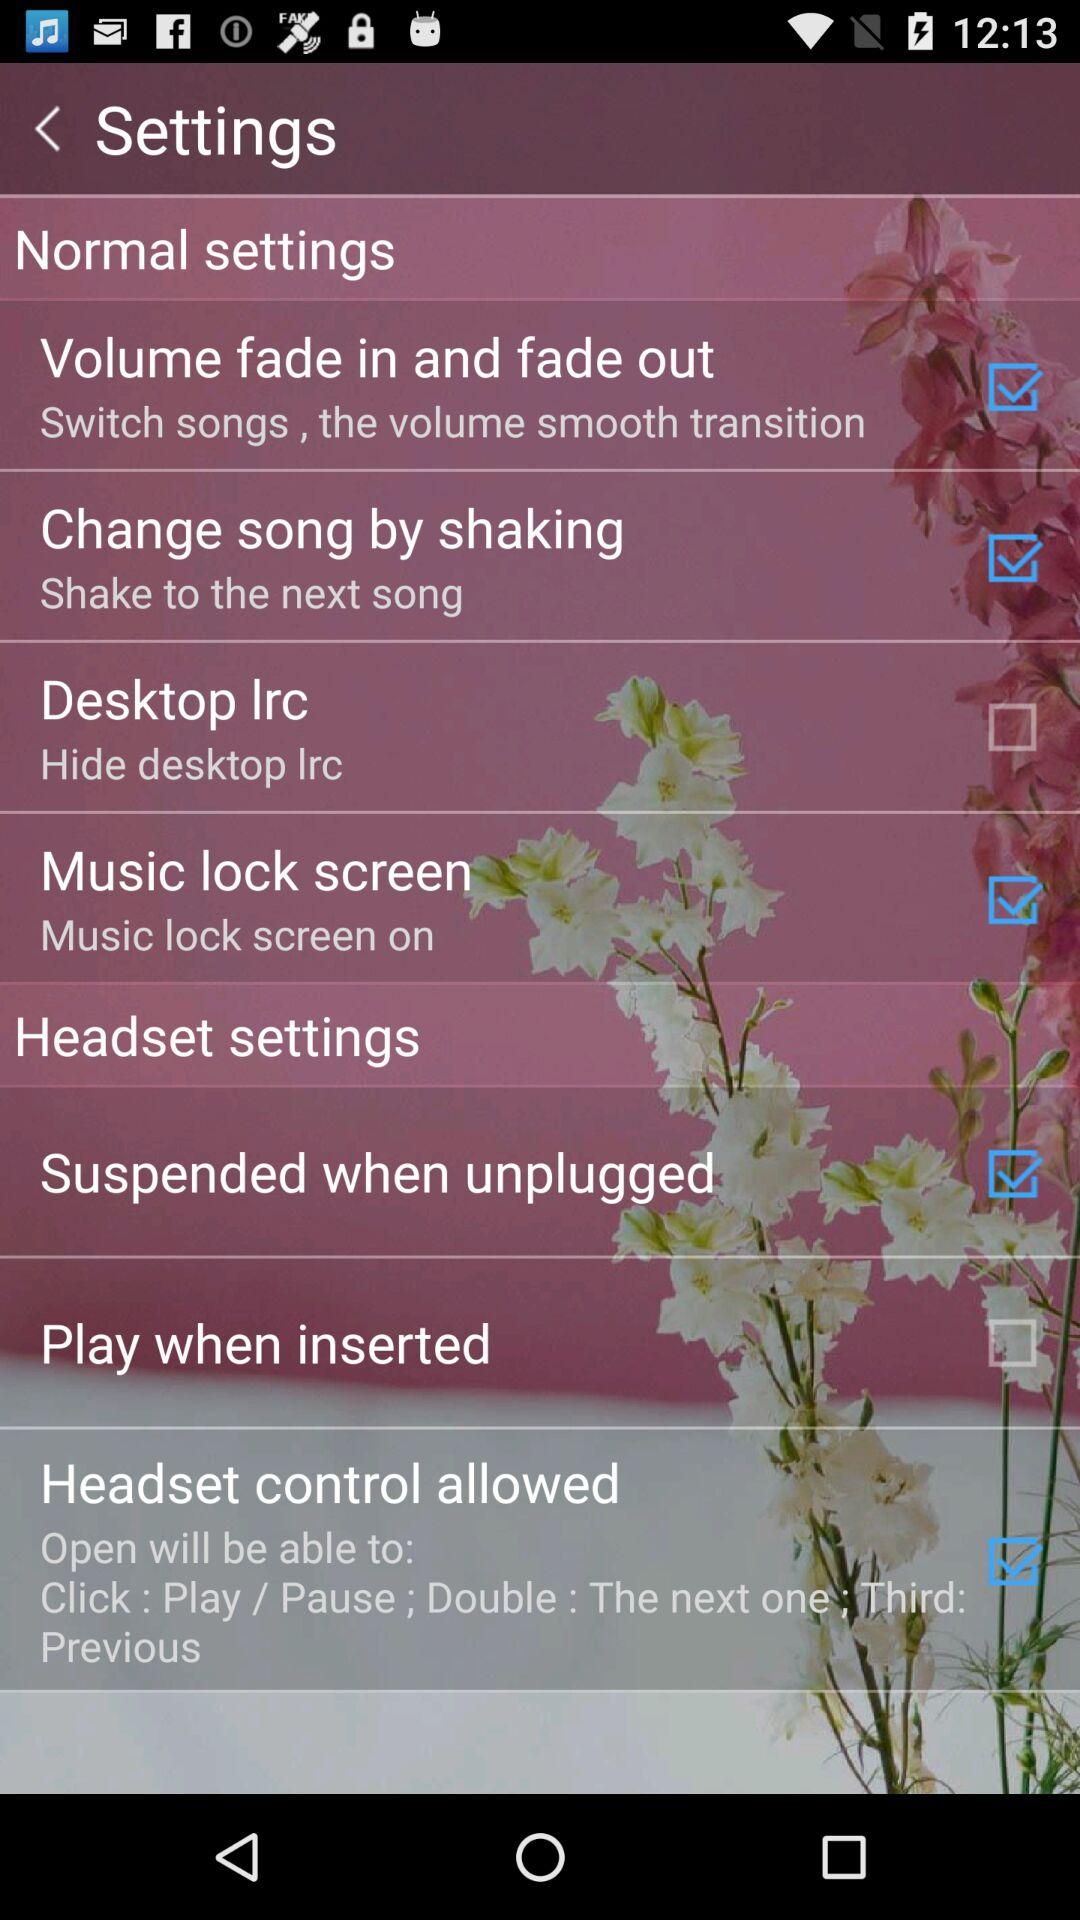How many checkboxes are in the headset settings section?
Answer the question using a single word or phrase. 3 